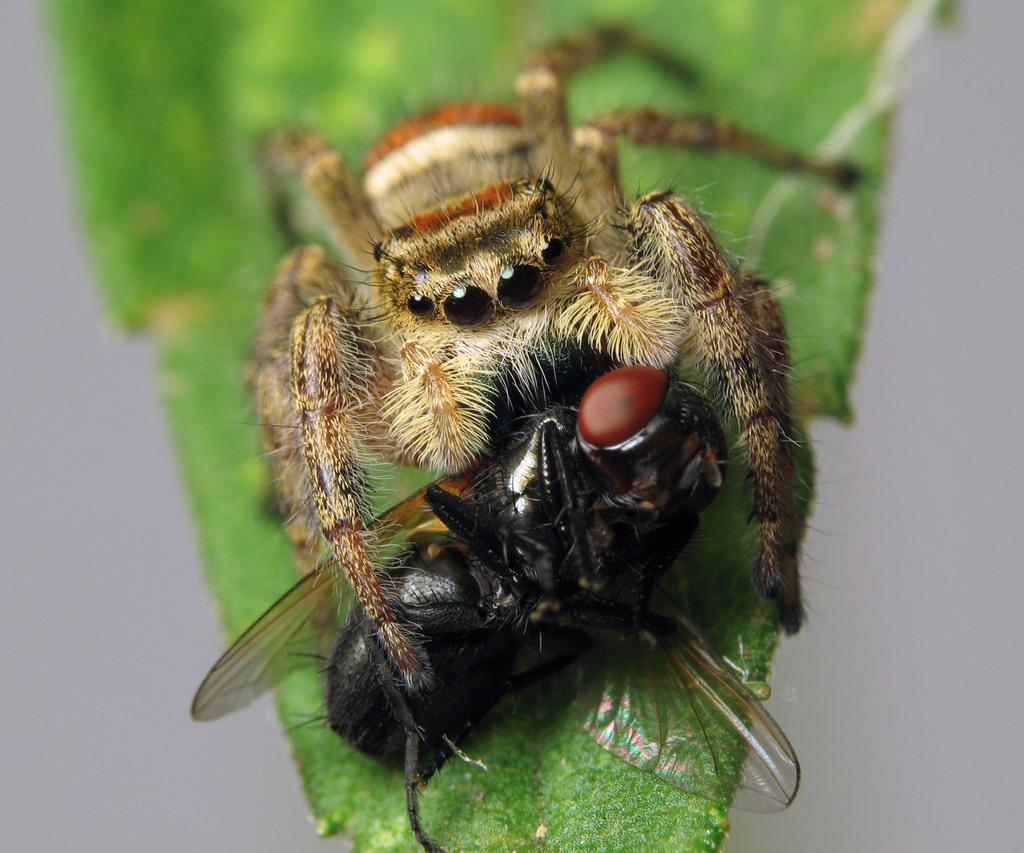What type of creature is present in the image? There is a spider in the image. Are there any other creatures in the image? Yes, there is an insect in the image. Where are the spider and insect located? Both the spider and insect are on a leaf. Can you describe the background of the image? The background of the image is blurred. What type of fold can be seen in the image? There is no fold present in the image; it features a spider and an insect on a leaf with a blurred background. 